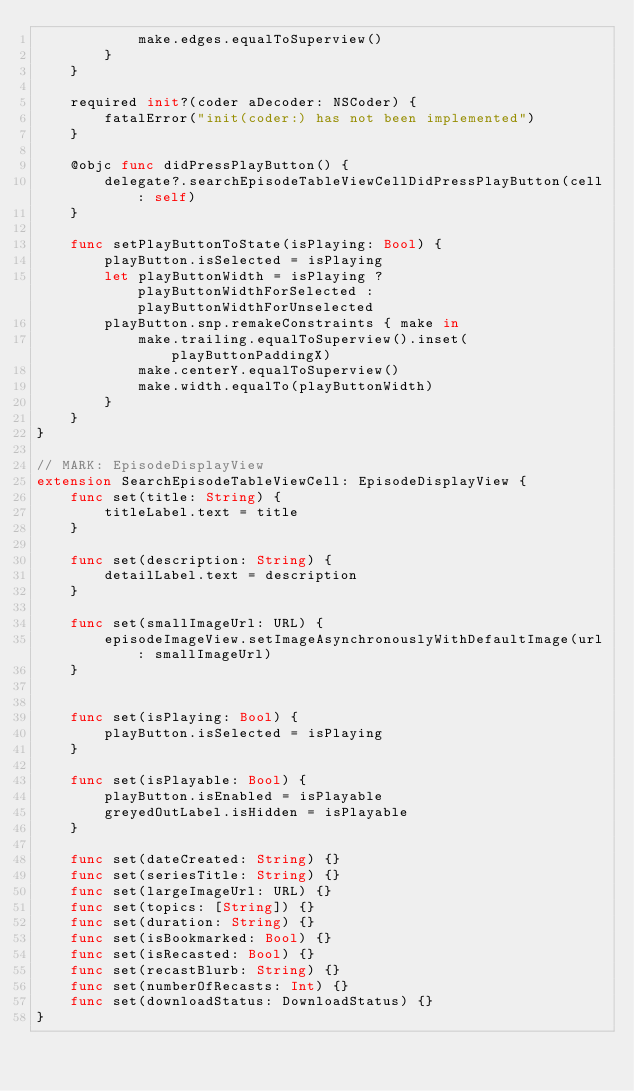Convert code to text. <code><loc_0><loc_0><loc_500><loc_500><_Swift_>            make.edges.equalToSuperview()
        }
    }

    required init?(coder aDecoder: NSCoder) {
        fatalError("init(coder:) has not been implemented")
    }

    @objc func didPressPlayButton() {
        delegate?.searchEpisodeTableViewCellDidPressPlayButton(cell: self)
    }
    
    func setPlayButtonToState(isPlaying: Bool) {
        playButton.isSelected = isPlaying
        let playButtonWidth = isPlaying ? playButtonWidthForSelected : playButtonWidthForUnselected
        playButton.snp.remakeConstraints { make in
            make.trailing.equalToSuperview().inset(playButtonPaddingX)
            make.centerY.equalToSuperview()
            make.width.equalTo(playButtonWidth)
        }
    }
}

// MARK: EpisodeDisplayView
extension SearchEpisodeTableViewCell: EpisodeDisplayView {
    func set(title: String) {
        titleLabel.text = title
    }

    func set(description: String) {
        detailLabel.text = description
    }

    func set(smallImageUrl: URL) {
        episodeImageView.setImageAsynchronouslyWithDefaultImage(url: smallImageUrl)
    }


    func set(isPlaying: Bool) {
        playButton.isSelected = isPlaying
    }

    func set(isPlayable: Bool) {
        playButton.isEnabled = isPlayable
        greyedOutLabel.isHidden = isPlayable
    }

    func set(dateCreated: String) {}
    func set(seriesTitle: String) {}
    func set(largeImageUrl: URL) {}
    func set(topics: [String]) {}
    func set(duration: String) {}
    func set(isBookmarked: Bool) {}
    func set(isRecasted: Bool) {}
    func set(recastBlurb: String) {}
    func set(numberOfRecasts: Int) {}
    func set(downloadStatus: DownloadStatus) {}
}
</code> 